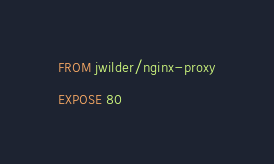Convert code to text. <code><loc_0><loc_0><loc_500><loc_500><_Dockerfile_>FROM jwilder/nginx-proxy

EXPOSE 80
</code> 